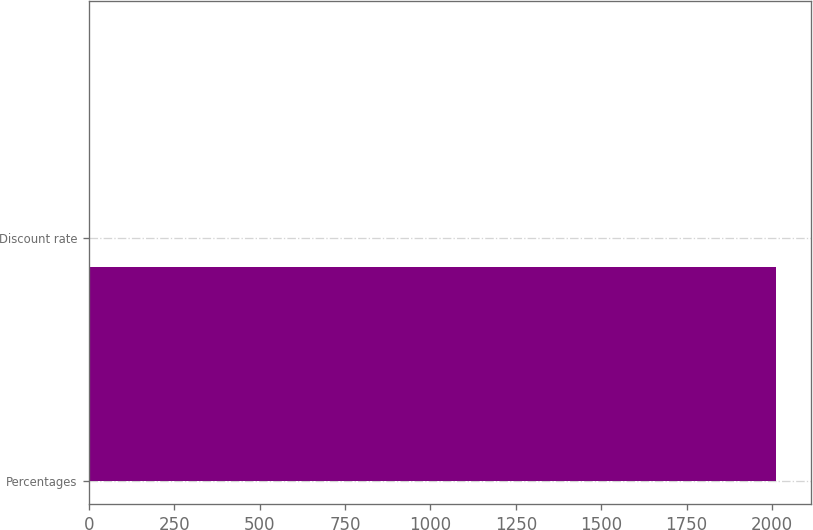<chart> <loc_0><loc_0><loc_500><loc_500><bar_chart><fcel>Percentages<fcel>Discount rate<nl><fcel>2013<fcel>4.13<nl></chart> 